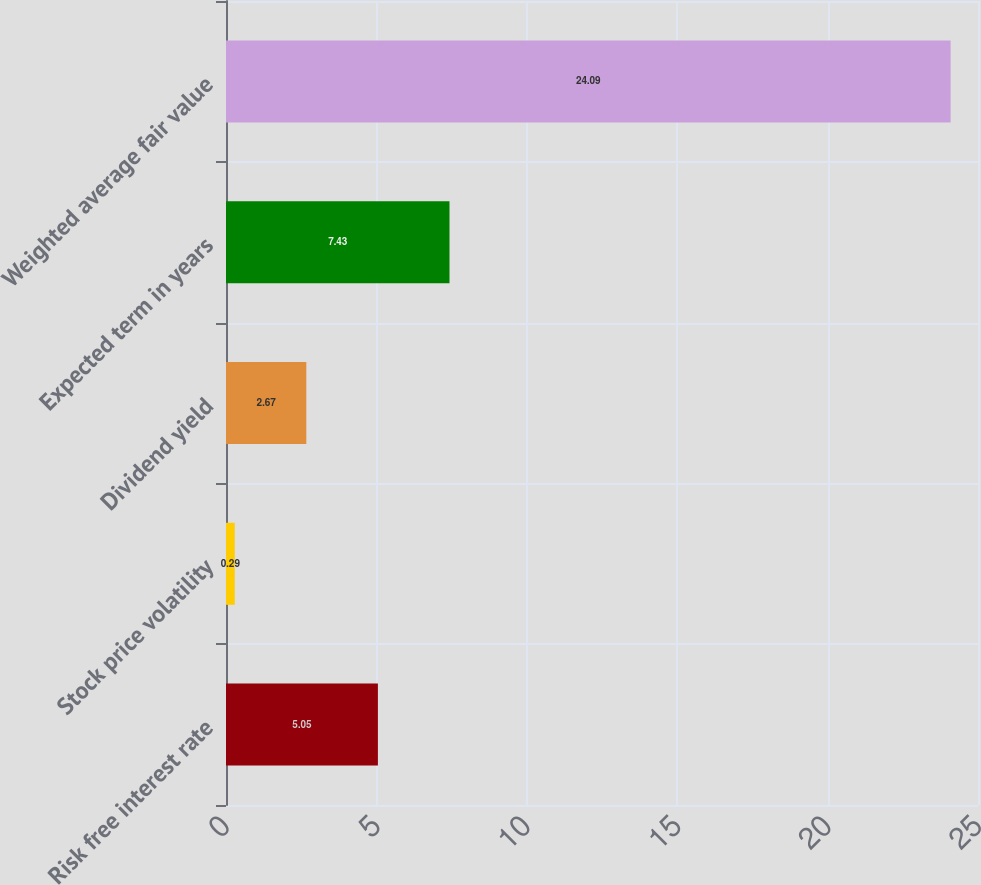<chart> <loc_0><loc_0><loc_500><loc_500><bar_chart><fcel>Risk free interest rate<fcel>Stock price volatility<fcel>Dividend yield<fcel>Expected term in years<fcel>Weighted average fair value<nl><fcel>5.05<fcel>0.29<fcel>2.67<fcel>7.43<fcel>24.09<nl></chart> 